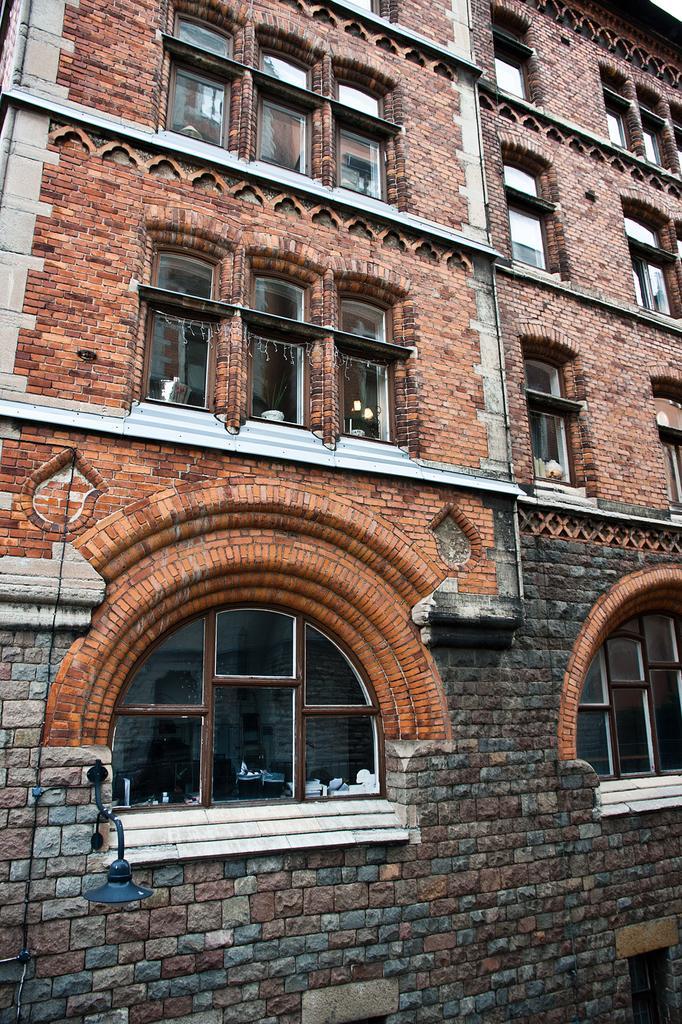Please provide a concise description of this image. This is the front view of a building where we can see glass windows. 